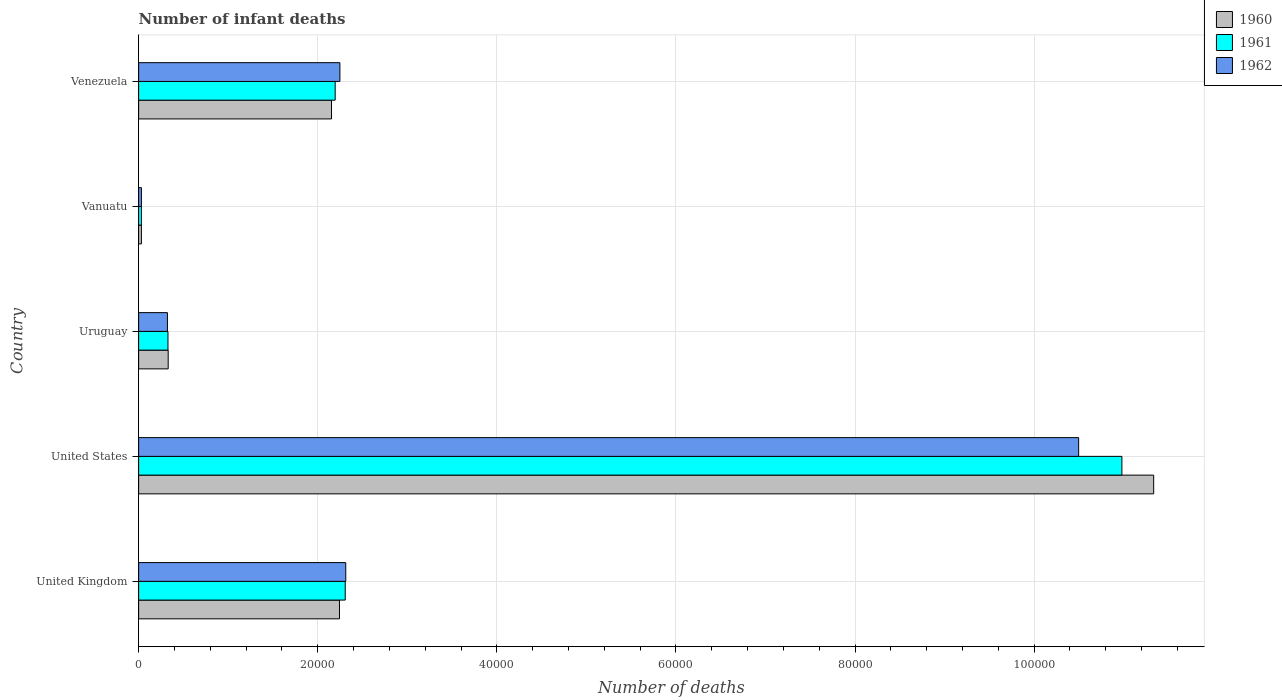How many different coloured bars are there?
Give a very brief answer. 3. How many groups of bars are there?
Your answer should be compact. 5. How many bars are there on the 3rd tick from the bottom?
Keep it short and to the point. 3. What is the label of the 2nd group of bars from the top?
Make the answer very short. Vanuatu. In how many cases, is the number of bars for a given country not equal to the number of legend labels?
Offer a very short reply. 0. What is the number of infant deaths in 1962 in United Kingdom?
Give a very brief answer. 2.31e+04. Across all countries, what is the maximum number of infant deaths in 1960?
Ensure brevity in your answer.  1.13e+05. Across all countries, what is the minimum number of infant deaths in 1960?
Provide a succinct answer. 311. In which country was the number of infant deaths in 1962 minimum?
Keep it short and to the point. Vanuatu. What is the total number of infant deaths in 1961 in the graph?
Keep it short and to the point. 1.58e+05. What is the difference between the number of infant deaths in 1961 in Vanuatu and that in Venezuela?
Offer a terse response. -2.16e+04. What is the difference between the number of infant deaths in 1961 in United Kingdom and the number of infant deaths in 1962 in Vanuatu?
Offer a terse response. 2.28e+04. What is the average number of infant deaths in 1960 per country?
Keep it short and to the point. 3.22e+04. What is the difference between the number of infant deaths in 1961 and number of infant deaths in 1962 in United States?
Make the answer very short. 4830. What is the ratio of the number of infant deaths in 1962 in Vanuatu to that in Venezuela?
Offer a terse response. 0.01. What is the difference between the highest and the second highest number of infant deaths in 1960?
Your response must be concise. 9.09e+04. What is the difference between the highest and the lowest number of infant deaths in 1961?
Make the answer very short. 1.09e+05. Is the sum of the number of infant deaths in 1960 in United States and Vanuatu greater than the maximum number of infant deaths in 1961 across all countries?
Ensure brevity in your answer.  Yes. How many bars are there?
Make the answer very short. 15. How many legend labels are there?
Your response must be concise. 3. How are the legend labels stacked?
Your answer should be very brief. Vertical. What is the title of the graph?
Provide a succinct answer. Number of infant deaths. Does "1971" appear as one of the legend labels in the graph?
Provide a short and direct response. No. What is the label or title of the X-axis?
Offer a very short reply. Number of deaths. What is the Number of deaths of 1960 in United Kingdom?
Keep it short and to the point. 2.24e+04. What is the Number of deaths in 1961 in United Kingdom?
Your answer should be very brief. 2.31e+04. What is the Number of deaths of 1962 in United Kingdom?
Make the answer very short. 2.31e+04. What is the Number of deaths in 1960 in United States?
Your response must be concise. 1.13e+05. What is the Number of deaths of 1961 in United States?
Your answer should be compact. 1.10e+05. What is the Number of deaths of 1962 in United States?
Give a very brief answer. 1.05e+05. What is the Number of deaths in 1960 in Uruguay?
Give a very brief answer. 3301. What is the Number of deaths in 1961 in Uruguay?
Offer a terse response. 3277. What is the Number of deaths in 1962 in Uruguay?
Keep it short and to the point. 3216. What is the Number of deaths of 1960 in Vanuatu?
Provide a succinct answer. 311. What is the Number of deaths of 1961 in Vanuatu?
Ensure brevity in your answer.  311. What is the Number of deaths in 1962 in Vanuatu?
Keep it short and to the point. 311. What is the Number of deaths of 1960 in Venezuela?
Give a very brief answer. 2.15e+04. What is the Number of deaths of 1961 in Venezuela?
Your answer should be very brief. 2.19e+04. What is the Number of deaths in 1962 in Venezuela?
Provide a short and direct response. 2.25e+04. Across all countries, what is the maximum Number of deaths in 1960?
Offer a very short reply. 1.13e+05. Across all countries, what is the maximum Number of deaths of 1961?
Give a very brief answer. 1.10e+05. Across all countries, what is the maximum Number of deaths in 1962?
Make the answer very short. 1.05e+05. Across all countries, what is the minimum Number of deaths in 1960?
Provide a short and direct response. 311. Across all countries, what is the minimum Number of deaths of 1961?
Give a very brief answer. 311. Across all countries, what is the minimum Number of deaths in 1962?
Your answer should be very brief. 311. What is the total Number of deaths of 1960 in the graph?
Keep it short and to the point. 1.61e+05. What is the total Number of deaths in 1961 in the graph?
Provide a succinct answer. 1.58e+05. What is the total Number of deaths of 1962 in the graph?
Your response must be concise. 1.54e+05. What is the difference between the Number of deaths in 1960 in United Kingdom and that in United States?
Keep it short and to the point. -9.09e+04. What is the difference between the Number of deaths of 1961 in United Kingdom and that in United States?
Your answer should be very brief. -8.67e+04. What is the difference between the Number of deaths of 1962 in United Kingdom and that in United States?
Ensure brevity in your answer.  -8.18e+04. What is the difference between the Number of deaths in 1960 in United Kingdom and that in Uruguay?
Your response must be concise. 1.91e+04. What is the difference between the Number of deaths of 1961 in United Kingdom and that in Uruguay?
Provide a succinct answer. 1.98e+04. What is the difference between the Number of deaths in 1962 in United Kingdom and that in Uruguay?
Your response must be concise. 1.99e+04. What is the difference between the Number of deaths of 1960 in United Kingdom and that in Vanuatu?
Keep it short and to the point. 2.21e+04. What is the difference between the Number of deaths of 1961 in United Kingdom and that in Vanuatu?
Ensure brevity in your answer.  2.28e+04. What is the difference between the Number of deaths of 1962 in United Kingdom and that in Vanuatu?
Keep it short and to the point. 2.28e+04. What is the difference between the Number of deaths of 1960 in United Kingdom and that in Venezuela?
Provide a succinct answer. 890. What is the difference between the Number of deaths in 1961 in United Kingdom and that in Venezuela?
Make the answer very short. 1124. What is the difference between the Number of deaths of 1962 in United Kingdom and that in Venezuela?
Keep it short and to the point. 657. What is the difference between the Number of deaths of 1960 in United States and that in Uruguay?
Ensure brevity in your answer.  1.10e+05. What is the difference between the Number of deaths in 1961 in United States and that in Uruguay?
Give a very brief answer. 1.07e+05. What is the difference between the Number of deaths of 1962 in United States and that in Uruguay?
Keep it short and to the point. 1.02e+05. What is the difference between the Number of deaths in 1960 in United States and that in Vanuatu?
Offer a very short reply. 1.13e+05. What is the difference between the Number of deaths in 1961 in United States and that in Vanuatu?
Your response must be concise. 1.09e+05. What is the difference between the Number of deaths in 1962 in United States and that in Vanuatu?
Your answer should be very brief. 1.05e+05. What is the difference between the Number of deaths in 1960 in United States and that in Venezuela?
Keep it short and to the point. 9.18e+04. What is the difference between the Number of deaths of 1961 in United States and that in Venezuela?
Provide a succinct answer. 8.79e+04. What is the difference between the Number of deaths in 1962 in United States and that in Venezuela?
Offer a terse response. 8.25e+04. What is the difference between the Number of deaths in 1960 in Uruguay and that in Vanuatu?
Your answer should be compact. 2990. What is the difference between the Number of deaths in 1961 in Uruguay and that in Vanuatu?
Ensure brevity in your answer.  2966. What is the difference between the Number of deaths in 1962 in Uruguay and that in Vanuatu?
Provide a short and direct response. 2905. What is the difference between the Number of deaths in 1960 in Uruguay and that in Venezuela?
Ensure brevity in your answer.  -1.82e+04. What is the difference between the Number of deaths of 1961 in Uruguay and that in Venezuela?
Offer a terse response. -1.87e+04. What is the difference between the Number of deaths of 1962 in Uruguay and that in Venezuela?
Provide a succinct answer. -1.93e+04. What is the difference between the Number of deaths of 1960 in Vanuatu and that in Venezuela?
Offer a very short reply. -2.12e+04. What is the difference between the Number of deaths in 1961 in Vanuatu and that in Venezuela?
Ensure brevity in your answer.  -2.16e+04. What is the difference between the Number of deaths of 1962 in Vanuatu and that in Venezuela?
Provide a short and direct response. -2.22e+04. What is the difference between the Number of deaths in 1960 in United Kingdom and the Number of deaths in 1961 in United States?
Ensure brevity in your answer.  -8.74e+04. What is the difference between the Number of deaths in 1960 in United Kingdom and the Number of deaths in 1962 in United States?
Offer a terse response. -8.25e+04. What is the difference between the Number of deaths of 1961 in United Kingdom and the Number of deaths of 1962 in United States?
Your answer should be very brief. -8.19e+04. What is the difference between the Number of deaths in 1960 in United Kingdom and the Number of deaths in 1961 in Uruguay?
Your answer should be very brief. 1.92e+04. What is the difference between the Number of deaths in 1960 in United Kingdom and the Number of deaths in 1962 in Uruguay?
Your response must be concise. 1.92e+04. What is the difference between the Number of deaths in 1961 in United Kingdom and the Number of deaths in 1962 in Uruguay?
Keep it short and to the point. 1.99e+04. What is the difference between the Number of deaths in 1960 in United Kingdom and the Number of deaths in 1961 in Vanuatu?
Make the answer very short. 2.21e+04. What is the difference between the Number of deaths of 1960 in United Kingdom and the Number of deaths of 1962 in Vanuatu?
Ensure brevity in your answer.  2.21e+04. What is the difference between the Number of deaths in 1961 in United Kingdom and the Number of deaths in 1962 in Vanuatu?
Keep it short and to the point. 2.28e+04. What is the difference between the Number of deaths in 1960 in United Kingdom and the Number of deaths in 1961 in Venezuela?
Your answer should be compact. 482. What is the difference between the Number of deaths of 1960 in United Kingdom and the Number of deaths of 1962 in Venezuela?
Your response must be concise. -45. What is the difference between the Number of deaths of 1961 in United Kingdom and the Number of deaths of 1962 in Venezuela?
Provide a succinct answer. 597. What is the difference between the Number of deaths in 1960 in United States and the Number of deaths in 1961 in Uruguay?
Provide a short and direct response. 1.10e+05. What is the difference between the Number of deaths of 1960 in United States and the Number of deaths of 1962 in Uruguay?
Your answer should be very brief. 1.10e+05. What is the difference between the Number of deaths of 1961 in United States and the Number of deaths of 1962 in Uruguay?
Ensure brevity in your answer.  1.07e+05. What is the difference between the Number of deaths of 1960 in United States and the Number of deaths of 1961 in Vanuatu?
Ensure brevity in your answer.  1.13e+05. What is the difference between the Number of deaths of 1960 in United States and the Number of deaths of 1962 in Vanuatu?
Your response must be concise. 1.13e+05. What is the difference between the Number of deaths in 1961 in United States and the Number of deaths in 1962 in Vanuatu?
Your answer should be compact. 1.09e+05. What is the difference between the Number of deaths in 1960 in United States and the Number of deaths in 1961 in Venezuela?
Make the answer very short. 9.14e+04. What is the difference between the Number of deaths of 1960 in United States and the Number of deaths of 1962 in Venezuela?
Ensure brevity in your answer.  9.09e+04. What is the difference between the Number of deaths of 1961 in United States and the Number of deaths of 1962 in Venezuela?
Provide a succinct answer. 8.73e+04. What is the difference between the Number of deaths of 1960 in Uruguay and the Number of deaths of 1961 in Vanuatu?
Your answer should be very brief. 2990. What is the difference between the Number of deaths in 1960 in Uruguay and the Number of deaths in 1962 in Vanuatu?
Offer a terse response. 2990. What is the difference between the Number of deaths of 1961 in Uruguay and the Number of deaths of 1962 in Vanuatu?
Give a very brief answer. 2966. What is the difference between the Number of deaths in 1960 in Uruguay and the Number of deaths in 1961 in Venezuela?
Offer a very short reply. -1.86e+04. What is the difference between the Number of deaths in 1960 in Uruguay and the Number of deaths in 1962 in Venezuela?
Your answer should be compact. -1.92e+04. What is the difference between the Number of deaths in 1961 in Uruguay and the Number of deaths in 1962 in Venezuela?
Your answer should be very brief. -1.92e+04. What is the difference between the Number of deaths in 1960 in Vanuatu and the Number of deaths in 1961 in Venezuela?
Keep it short and to the point. -2.16e+04. What is the difference between the Number of deaths in 1960 in Vanuatu and the Number of deaths in 1962 in Venezuela?
Your answer should be compact. -2.22e+04. What is the difference between the Number of deaths in 1961 in Vanuatu and the Number of deaths in 1962 in Venezuela?
Make the answer very short. -2.22e+04. What is the average Number of deaths in 1960 per country?
Offer a terse response. 3.22e+04. What is the average Number of deaths of 1961 per country?
Offer a terse response. 3.17e+04. What is the average Number of deaths of 1962 per country?
Offer a very short reply. 3.08e+04. What is the difference between the Number of deaths in 1960 and Number of deaths in 1961 in United Kingdom?
Keep it short and to the point. -642. What is the difference between the Number of deaths of 1960 and Number of deaths of 1962 in United Kingdom?
Provide a succinct answer. -702. What is the difference between the Number of deaths in 1961 and Number of deaths in 1962 in United Kingdom?
Your response must be concise. -60. What is the difference between the Number of deaths in 1960 and Number of deaths in 1961 in United States?
Keep it short and to the point. 3550. What is the difference between the Number of deaths of 1960 and Number of deaths of 1962 in United States?
Ensure brevity in your answer.  8380. What is the difference between the Number of deaths in 1961 and Number of deaths in 1962 in United States?
Keep it short and to the point. 4830. What is the difference between the Number of deaths of 1961 and Number of deaths of 1962 in Uruguay?
Provide a short and direct response. 61. What is the difference between the Number of deaths of 1960 and Number of deaths of 1961 in Vanuatu?
Offer a very short reply. 0. What is the difference between the Number of deaths in 1960 and Number of deaths in 1962 in Vanuatu?
Keep it short and to the point. 0. What is the difference between the Number of deaths of 1961 and Number of deaths of 1962 in Vanuatu?
Your response must be concise. 0. What is the difference between the Number of deaths in 1960 and Number of deaths in 1961 in Venezuela?
Provide a succinct answer. -408. What is the difference between the Number of deaths in 1960 and Number of deaths in 1962 in Venezuela?
Offer a terse response. -935. What is the difference between the Number of deaths of 1961 and Number of deaths of 1962 in Venezuela?
Offer a very short reply. -527. What is the ratio of the Number of deaths in 1960 in United Kingdom to that in United States?
Keep it short and to the point. 0.2. What is the ratio of the Number of deaths of 1961 in United Kingdom to that in United States?
Offer a terse response. 0.21. What is the ratio of the Number of deaths of 1962 in United Kingdom to that in United States?
Provide a short and direct response. 0.22. What is the ratio of the Number of deaths in 1960 in United Kingdom to that in Uruguay?
Your response must be concise. 6.79. What is the ratio of the Number of deaths of 1961 in United Kingdom to that in Uruguay?
Provide a short and direct response. 7.04. What is the ratio of the Number of deaths in 1962 in United Kingdom to that in Uruguay?
Ensure brevity in your answer.  7.19. What is the ratio of the Number of deaths of 1960 in United Kingdom to that in Vanuatu?
Provide a succinct answer. 72.12. What is the ratio of the Number of deaths in 1961 in United Kingdom to that in Vanuatu?
Provide a short and direct response. 74.19. What is the ratio of the Number of deaths of 1962 in United Kingdom to that in Vanuatu?
Provide a short and direct response. 74.38. What is the ratio of the Number of deaths of 1960 in United Kingdom to that in Venezuela?
Make the answer very short. 1.04. What is the ratio of the Number of deaths of 1961 in United Kingdom to that in Venezuela?
Your answer should be compact. 1.05. What is the ratio of the Number of deaths in 1962 in United Kingdom to that in Venezuela?
Ensure brevity in your answer.  1.03. What is the ratio of the Number of deaths in 1960 in United States to that in Uruguay?
Provide a succinct answer. 34.34. What is the ratio of the Number of deaths in 1961 in United States to that in Uruguay?
Keep it short and to the point. 33.51. What is the ratio of the Number of deaths in 1962 in United States to that in Uruguay?
Provide a succinct answer. 32.64. What is the ratio of the Number of deaths in 1960 in United States to that in Vanuatu?
Offer a very short reply. 364.48. What is the ratio of the Number of deaths in 1961 in United States to that in Vanuatu?
Offer a terse response. 353.07. What is the ratio of the Number of deaths in 1962 in United States to that in Vanuatu?
Ensure brevity in your answer.  337.54. What is the ratio of the Number of deaths in 1960 in United States to that in Venezuela?
Ensure brevity in your answer.  5.26. What is the ratio of the Number of deaths of 1961 in United States to that in Venezuela?
Your answer should be very brief. 5. What is the ratio of the Number of deaths of 1962 in United States to that in Venezuela?
Offer a terse response. 4.67. What is the ratio of the Number of deaths in 1960 in Uruguay to that in Vanuatu?
Keep it short and to the point. 10.61. What is the ratio of the Number of deaths of 1961 in Uruguay to that in Vanuatu?
Make the answer very short. 10.54. What is the ratio of the Number of deaths in 1962 in Uruguay to that in Vanuatu?
Your answer should be very brief. 10.34. What is the ratio of the Number of deaths of 1960 in Uruguay to that in Venezuela?
Make the answer very short. 0.15. What is the ratio of the Number of deaths of 1961 in Uruguay to that in Venezuela?
Keep it short and to the point. 0.15. What is the ratio of the Number of deaths of 1962 in Uruguay to that in Venezuela?
Offer a very short reply. 0.14. What is the ratio of the Number of deaths of 1960 in Vanuatu to that in Venezuela?
Provide a succinct answer. 0.01. What is the ratio of the Number of deaths in 1961 in Vanuatu to that in Venezuela?
Your answer should be very brief. 0.01. What is the ratio of the Number of deaths of 1962 in Vanuatu to that in Venezuela?
Your response must be concise. 0.01. What is the difference between the highest and the second highest Number of deaths in 1960?
Provide a succinct answer. 9.09e+04. What is the difference between the highest and the second highest Number of deaths in 1961?
Ensure brevity in your answer.  8.67e+04. What is the difference between the highest and the second highest Number of deaths of 1962?
Ensure brevity in your answer.  8.18e+04. What is the difference between the highest and the lowest Number of deaths in 1960?
Your answer should be very brief. 1.13e+05. What is the difference between the highest and the lowest Number of deaths in 1961?
Provide a short and direct response. 1.09e+05. What is the difference between the highest and the lowest Number of deaths of 1962?
Provide a succinct answer. 1.05e+05. 